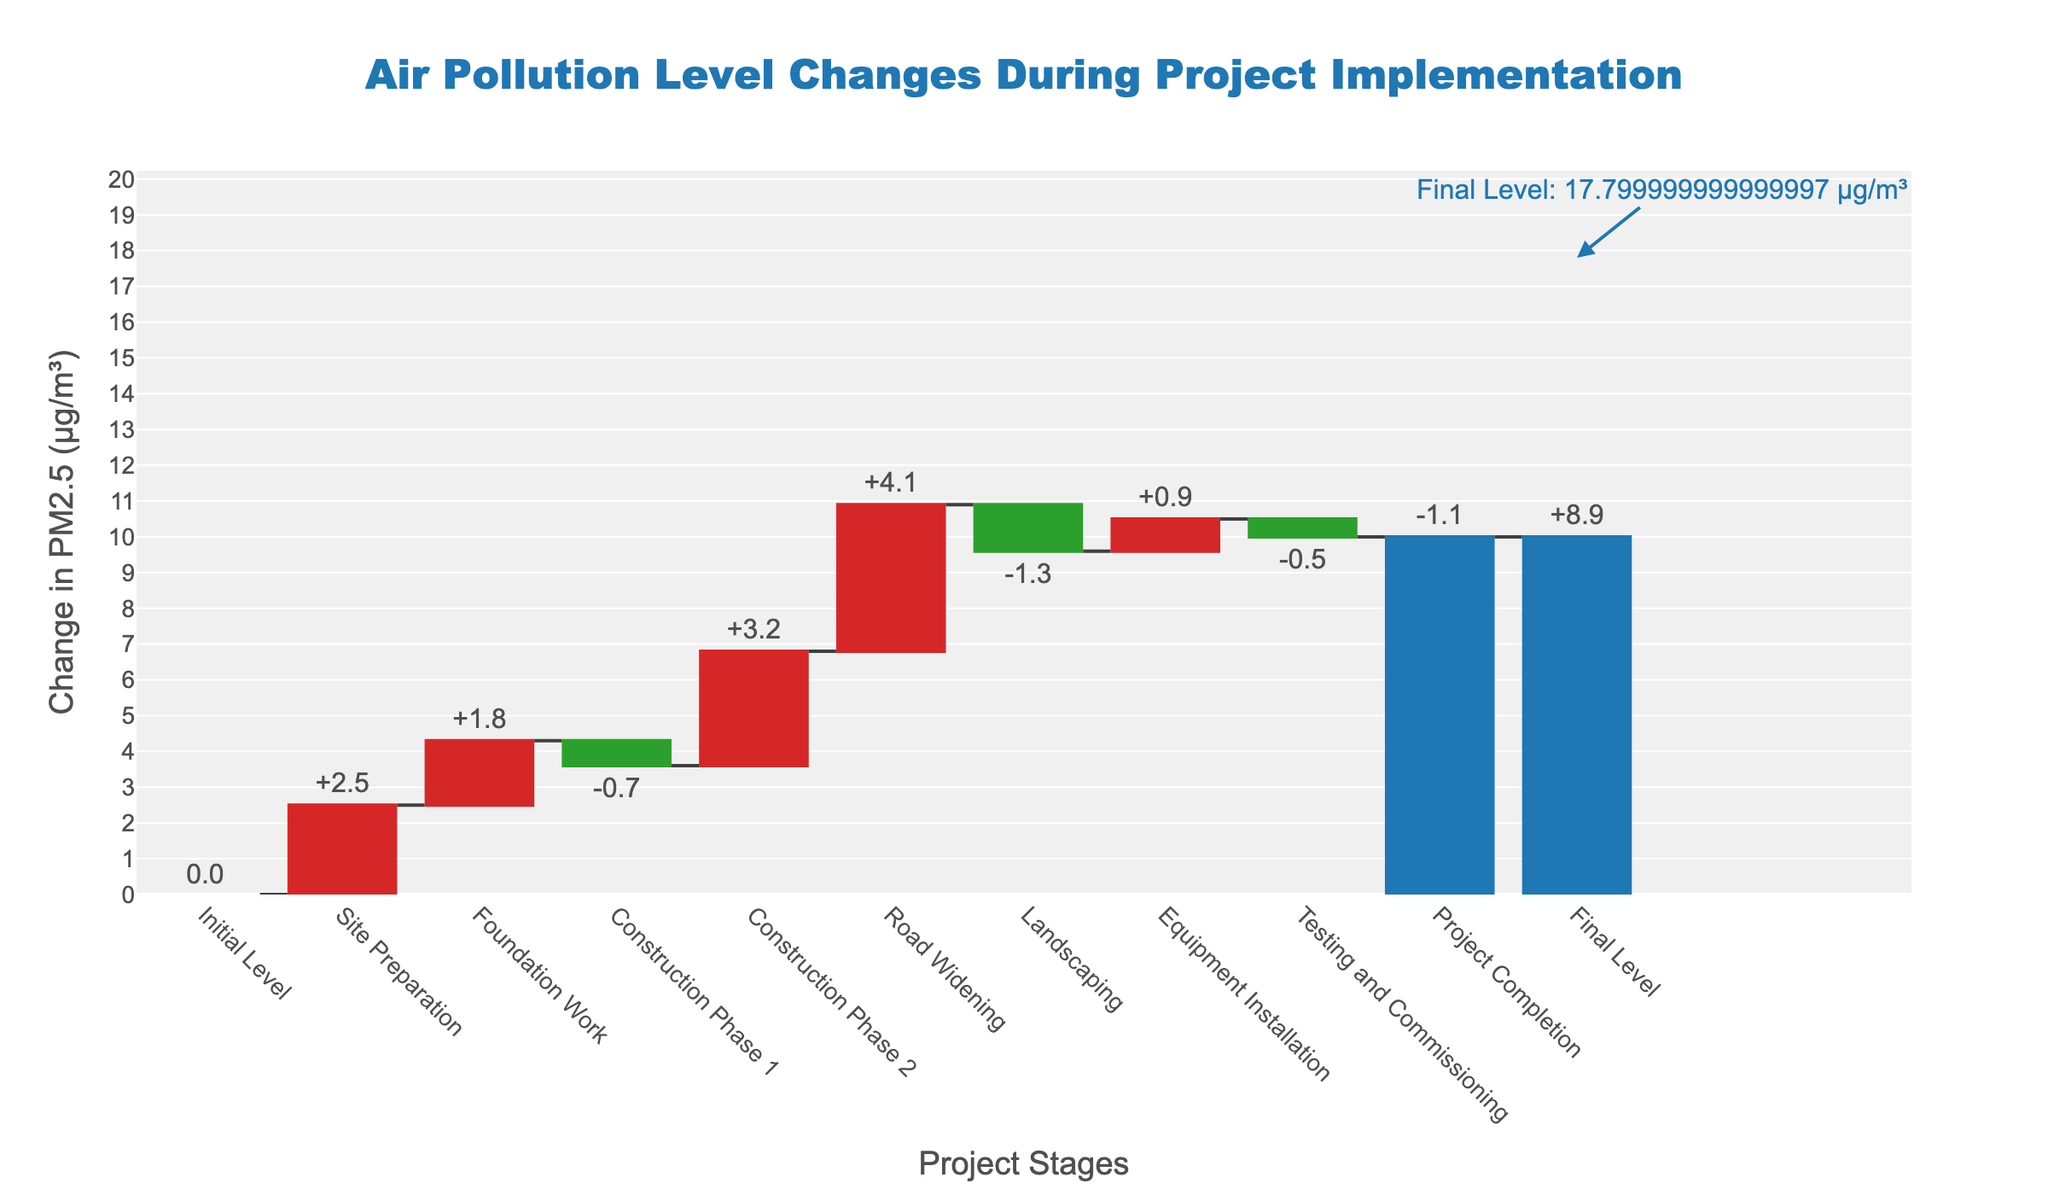What's the title of the waterfall chart? The waterfall chart title is displayed at the top center of the figure. It provides a summary description of what the chart represents.
Answer: Air Pollution Level Changes During Project Implementation What's the final level of PM2.5 at the project completion stage? The final level of PM2.5 is indicated in the figure with an annotation next to the last bar for "Final Level."
Answer: 8.9 µg/m³ What project stage contributed the most to the increase in PM2.5 levels? This requires identifying the stage with the highest positive change in PM2.5 from the figure.
Answer: Road Widening Which stages resulted in a decrease in PM2.5 levels, and what are their combined effects? Identify the stages with negative changes in PM2.5 and sum up their values. Construction Phase 1, Landscaping, Testing and Commissioning, and Project Completion are the negative contributors with changes of -0.7, -1.3, -0.5, and -1.1 respectively. Their combined effect is -3.6 µg/m³.
Answer: Construction Phase 1, Landscaping, Testing and Commissioning, Project Completion; -3.6 µg/m³ How many total stages resulted in an increase in PM2.5 levels? Count the stages with a positive change in PM2.5 from the figure. Site Preparation, Foundation Work, Construction Phase 2, Road Widening, and Equipment Installation are the stages with positive contributions.
Answer: 5 stages What is the cumulative effect of all stages on PM2.5 levels before reaching the final level? Sum all incremental changes from each stage to determine the cumulative effect before the final level. The sum is 2.5 (Site Preparation) + 1.8 (Foundation Work) - 0.7 (Construction Phase 1) + 3.2 (Construction Phase 2) + 4.1 (Road Widening) - 1.3 (Landscaping) + 0.9 (Equipment Installation) - 0.5 (Testing and Commissioning) - 1.1 (Project Completion) = 8.9 µg/m³.
Answer: 8.9 µg/m³ What is the change in PM2.5 levels during the Road Widening stage? Locate the bar corresponding to the Road Widening stage and read the value associated with it.
Answer: +4.1 µg/m³ Which stage countered the increase in PM2.5 by reducing it after the Road Widening stage? Identify the stage after Road Widening that has a negative change in PM2.5, which is Landscaping.
Answer: Landscaping How does the initial PM2.5 level compare to the final level? The initial level is 0, and the final level is 8.9. The difference is the final minus the initial value.
Answer: Initial: 0, Final: 8.9, Difference: +8.9 µg/m³ What is the effect of the "Testing and Commissioning" stage on PM2.5 levels? Locate the bar corresponding to "Testing and Commissioning" and read the change in PM2.5 value, which is negative.
Answer: -0.5 µg/m³ 